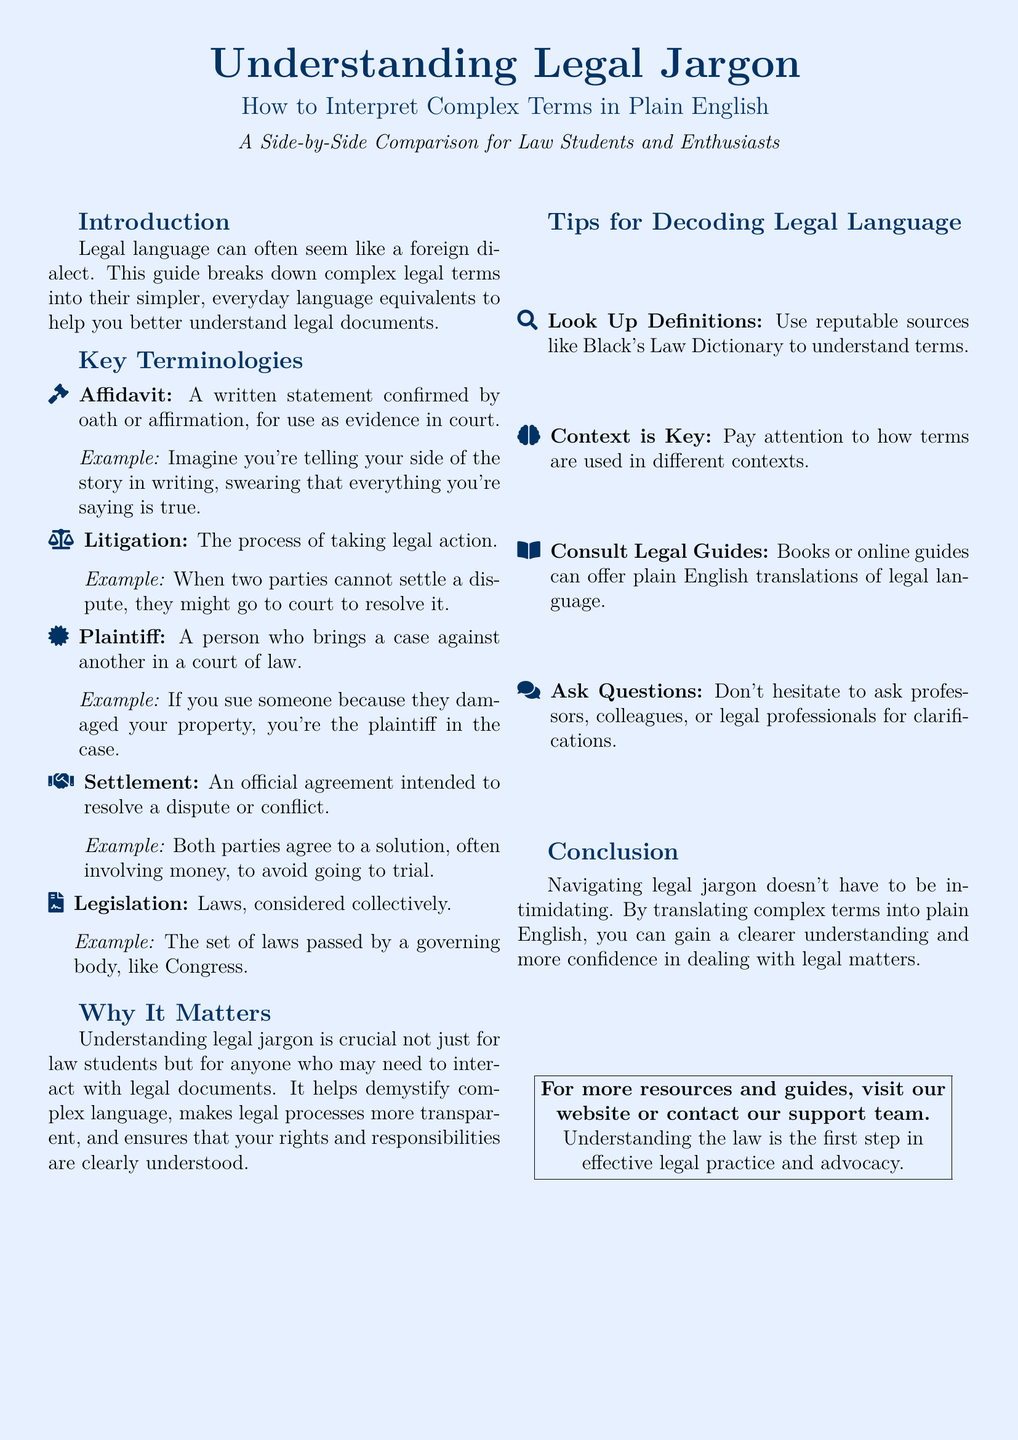What is the title of the flyer? The title is prominently displayed at the top of the flyer, summarizing the main topic.
Answer: Understanding Legal Jargon What is meant by "Affidavit"? This is an explanation of a specific legal term provided in the document.
Answer: A written statement confirmed by oath or affirmation, for use as evidence in court Who is referred to as the "Plaintiff"? This question seeks a definition given in the document about a specific role in court proceedings.
Answer: A person who brings a case against another in a court of law What does "Litigation" refer to? This term is defined in the document, indicating a process related to the law.
Answer: The process of taking legal action What is the purpose of interpreting legal jargon in plain English? The document explains the importance of understanding complex legal language.
Answer: To help demystify complex language and ensure that rights and responsibilities are clearly understood What is recommended for looking up legal definitions? The flyer provides suggestions on sources to consult for understanding legal terminology.
Answer: Black's Law Dictionary What does "Settlement" mean in legal terms? The document describes terms and offers examples to clarify their meaning.
Answer: An official agreement intended to resolve a dispute or conflict 